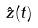<formula> <loc_0><loc_0><loc_500><loc_500>\hat { z } ( t )</formula> 